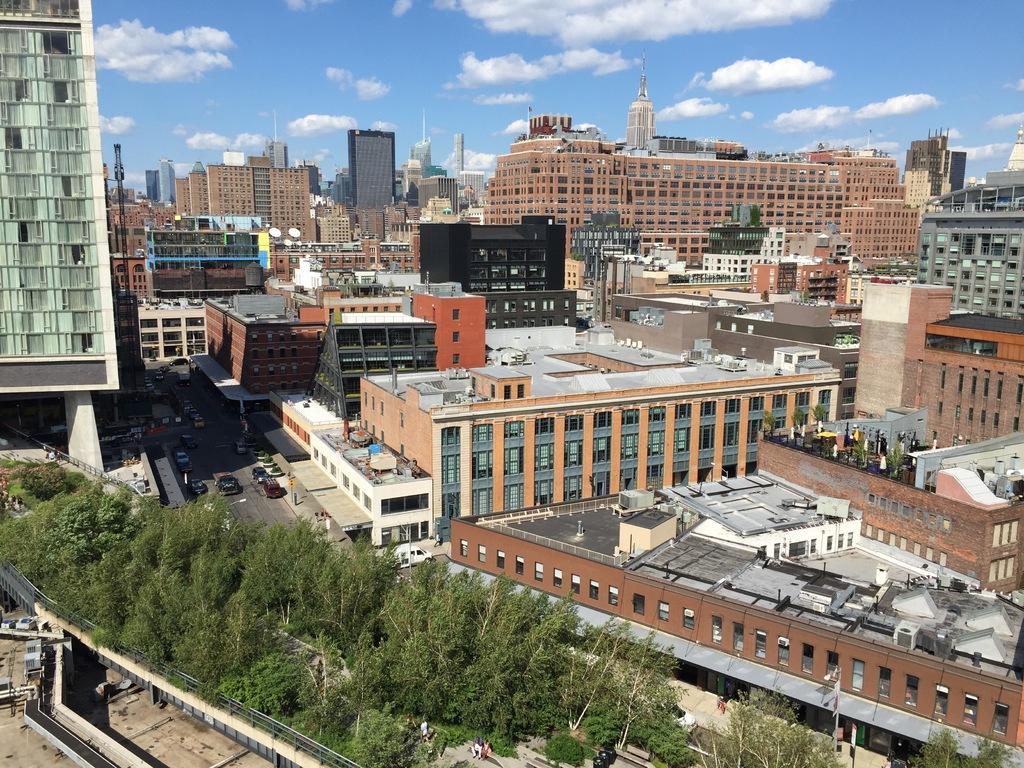In one or two sentences, can you explain what this image depicts? This is a aerial view image of a city, there are trees in the front followed by buildings in the background all over the image and above its sky with clouds. 